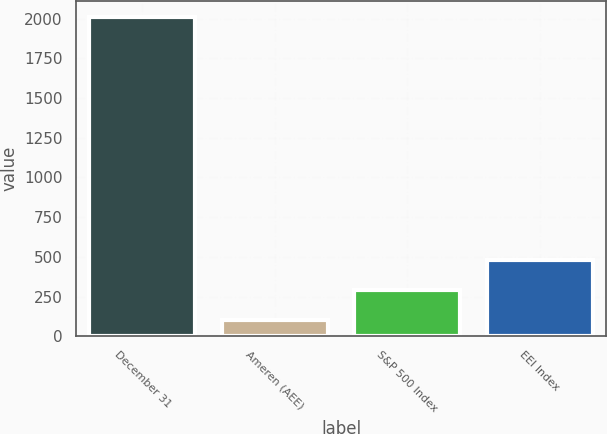<chart> <loc_0><loc_0><loc_500><loc_500><bar_chart><fcel>December 31<fcel>Ameren (AEE)<fcel>S&P 500 Index<fcel>EEI Index<nl><fcel>2012<fcel>100<fcel>291.2<fcel>482.4<nl></chart> 